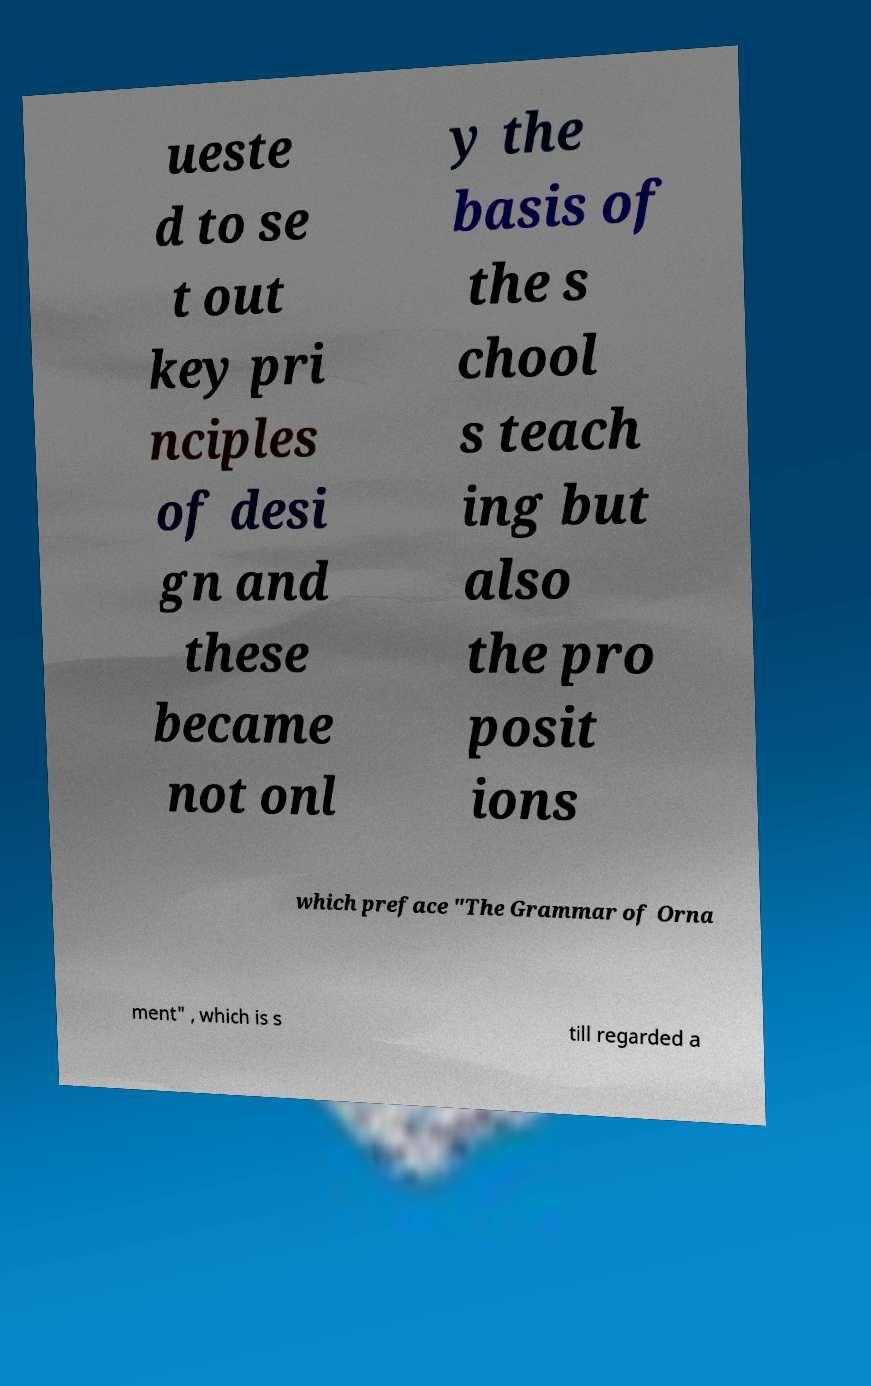Can you accurately transcribe the text from the provided image for me? ueste d to se t out key pri nciples of desi gn and these became not onl y the basis of the s chool s teach ing but also the pro posit ions which preface "The Grammar of Orna ment" , which is s till regarded a 